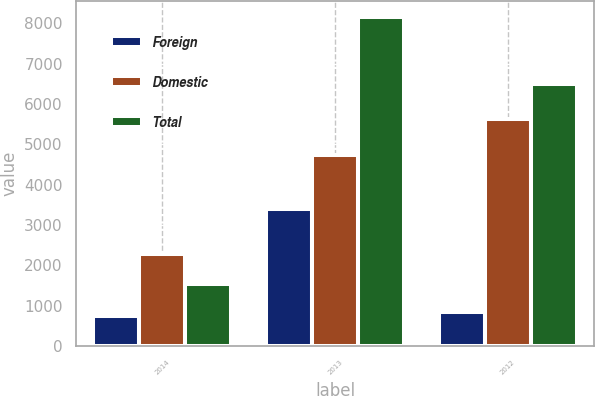Convert chart. <chart><loc_0><loc_0><loc_500><loc_500><stacked_bar_chart><ecel><fcel>2014<fcel>2013<fcel>2012<nl><fcel>Foreign<fcel>732<fcel>3399<fcel>852<nl><fcel>Domestic<fcel>2273<fcel>4747<fcel>5636<nl><fcel>Total<fcel>1541<fcel>8146<fcel>6488<nl></chart> 